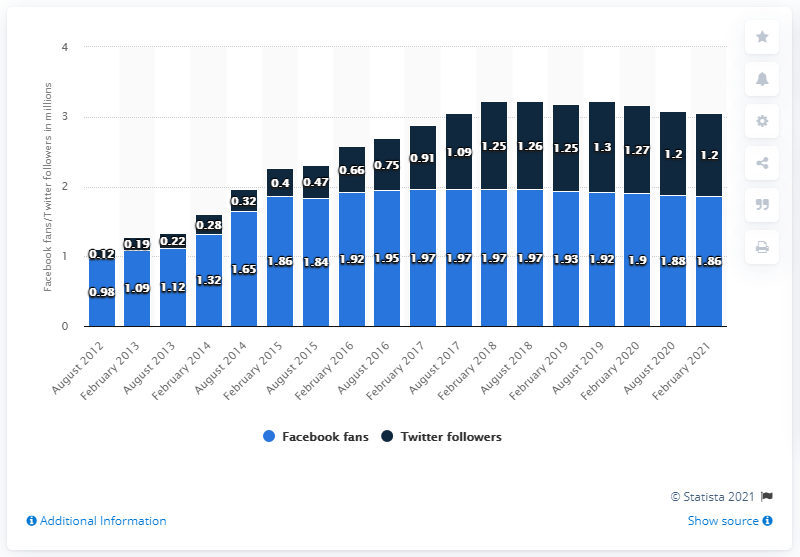Draw attention to some important aspects in this diagram. In August 2012, the number of Facebook fans was the lowest. The difference between the highest and lowest number of Twitter followers is 1.18. In February 2021, the Washington Football Team had 1.86 million Facebook followers. 